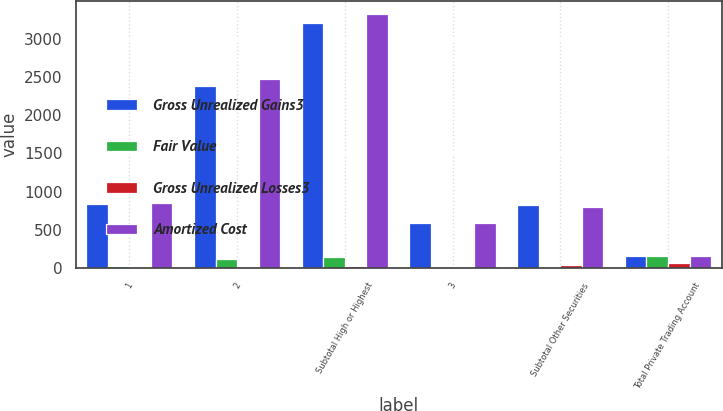Convert chart to OTSL. <chart><loc_0><loc_0><loc_500><loc_500><stacked_bar_chart><ecel><fcel>1<fcel>2<fcel>Subtotal High or Highest<fcel>3<fcel>Subtotal Other Securities<fcel>Total Private Trading Account<nl><fcel>Gross Unrealized Gains3<fcel>833<fcel>2379<fcel>3212<fcel>592<fcel>824<fcel>156<nl><fcel>Fair Value<fcel>32<fcel>116<fcel>148<fcel>11<fcel>16<fcel>164<nl><fcel>Gross Unrealized Losses3<fcel>12<fcel>18<fcel>30<fcel>18<fcel>40<fcel>70<nl><fcel>Amortized Cost<fcel>853<fcel>2477<fcel>3330<fcel>585<fcel>800<fcel>156<nl></chart> 